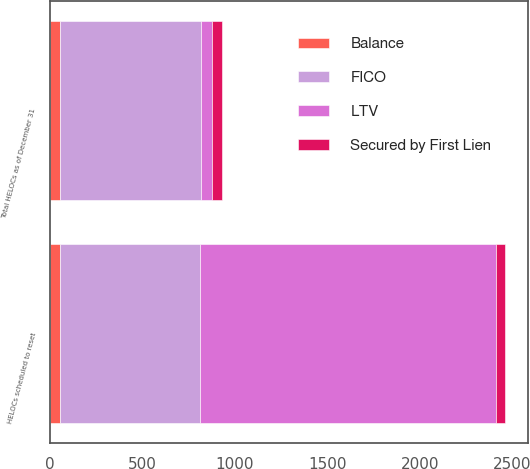Convert chart. <chart><loc_0><loc_0><loc_500><loc_500><stacked_bar_chart><ecel><fcel>Total HELOCs as of December 31<fcel>HELOCs scheduled to reset<nl><fcel>LTV<fcel>57<fcel>1598<nl><fcel>Balance<fcel>51<fcel>54<nl><fcel>FICO<fcel>766<fcel>758<nl><fcel>Secured by First Lien<fcel>57<fcel>51<nl></chart> 